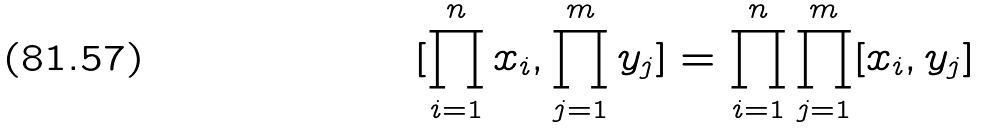Convert formula to latex. <formula><loc_0><loc_0><loc_500><loc_500>[ \prod _ { i = 1 } ^ { n } x _ { i } , \prod _ { j = 1 } ^ { m } y _ { j } ] = \prod _ { i = 1 } ^ { n } \prod _ { j = 1 } ^ { m } [ x _ { i } , y _ { j } ]</formula> 